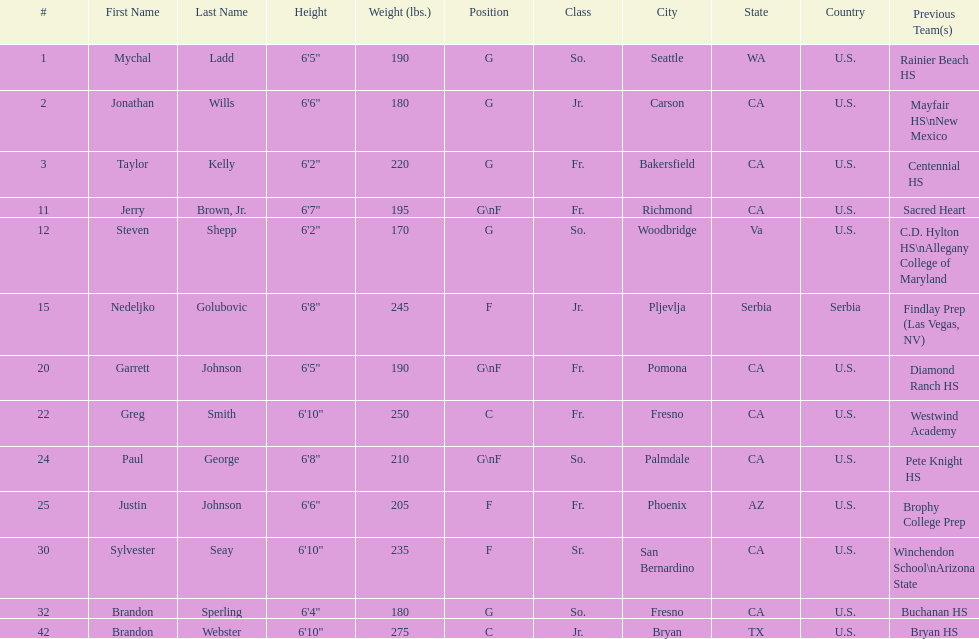Who is the only player not from the u. s.? Nedeljko Golubovic. 